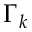Convert formula to latex. <formula><loc_0><loc_0><loc_500><loc_500>\Gamma _ { k }</formula> 